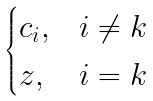Convert formula to latex. <formula><loc_0><loc_0><loc_500><loc_500>\begin{cases} c _ { i } , & i \ne k \\ z , & i = k \end{cases}</formula> 